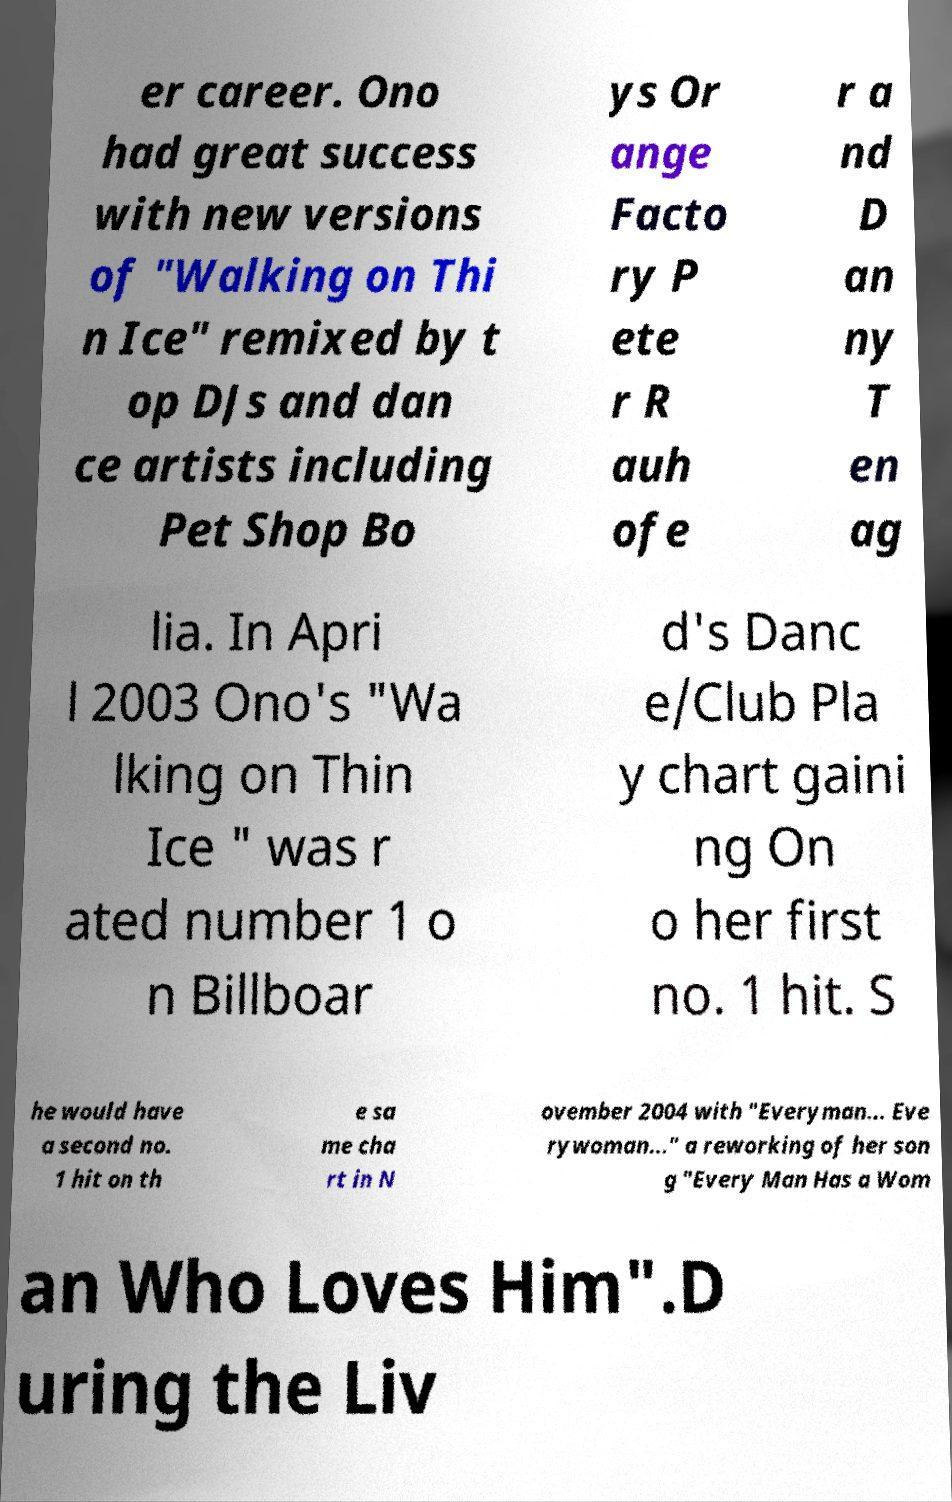Please identify and transcribe the text found in this image. er career. Ono had great success with new versions of "Walking on Thi n Ice" remixed by t op DJs and dan ce artists including Pet Shop Bo ys Or ange Facto ry P ete r R auh ofe r a nd D an ny T en ag lia. In Apri l 2003 Ono's "Wa lking on Thin Ice " was r ated number 1 o n Billboar d's Danc e/Club Pla y chart gaini ng On o her first no. 1 hit. S he would have a second no. 1 hit on th e sa me cha rt in N ovember 2004 with "Everyman... Eve rywoman..." a reworking of her son g "Every Man Has a Wom an Who Loves Him".D uring the Liv 